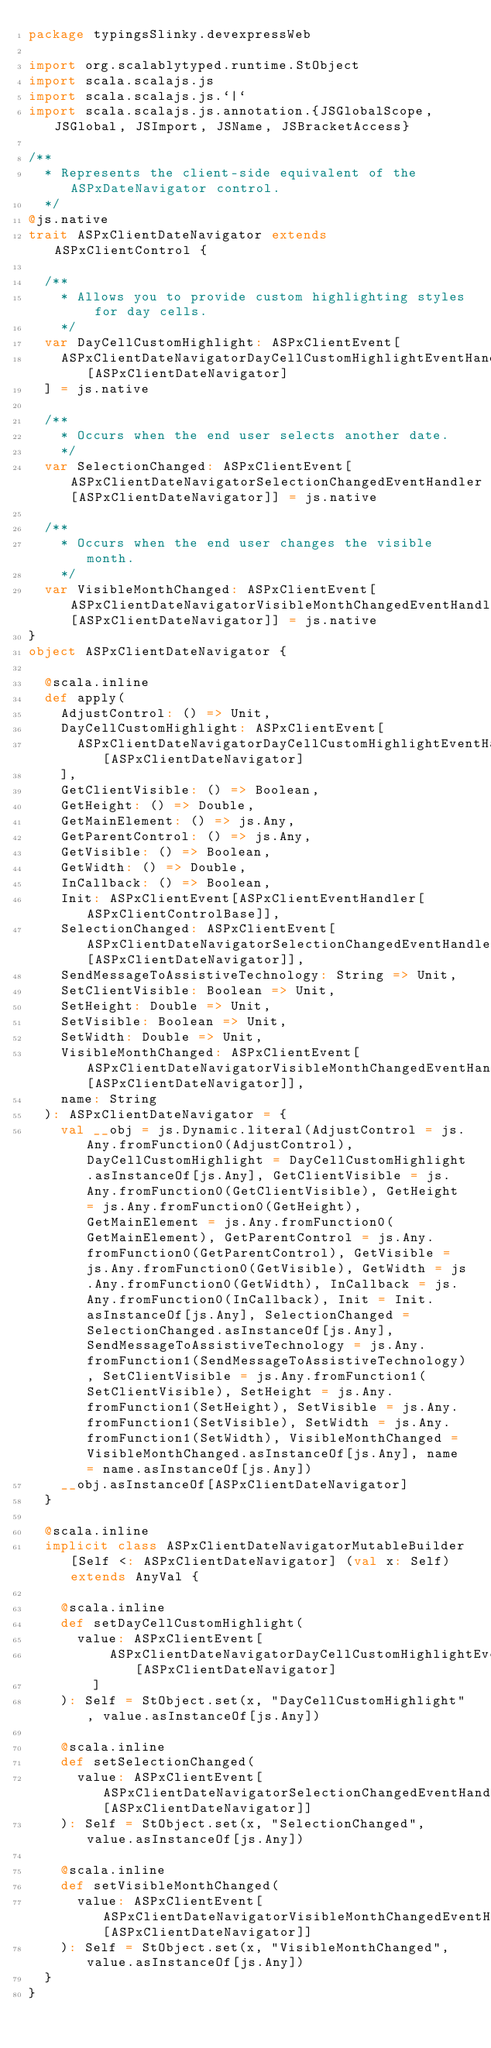<code> <loc_0><loc_0><loc_500><loc_500><_Scala_>package typingsSlinky.devexpressWeb

import org.scalablytyped.runtime.StObject
import scala.scalajs.js
import scala.scalajs.js.`|`
import scala.scalajs.js.annotation.{JSGlobalScope, JSGlobal, JSImport, JSName, JSBracketAccess}

/**
  * Represents the client-side equivalent of the ASPxDateNavigator control.
  */
@js.native
trait ASPxClientDateNavigator extends ASPxClientControl {
  
  /**
    * Allows you to provide custom highlighting styles for day cells.
    */
  var DayCellCustomHighlight: ASPxClientEvent[
    ASPxClientDateNavigatorDayCellCustomHighlightEventHandler[ASPxClientDateNavigator]
  ] = js.native
  
  /**
    * Occurs when the end user selects another date.
    */
  var SelectionChanged: ASPxClientEvent[ASPxClientDateNavigatorSelectionChangedEventHandler[ASPxClientDateNavigator]] = js.native
  
  /**
    * Occurs when the end user changes the visible month.
    */
  var VisibleMonthChanged: ASPxClientEvent[ASPxClientDateNavigatorVisibleMonthChangedEventHandler[ASPxClientDateNavigator]] = js.native
}
object ASPxClientDateNavigator {
  
  @scala.inline
  def apply(
    AdjustControl: () => Unit,
    DayCellCustomHighlight: ASPxClientEvent[
      ASPxClientDateNavigatorDayCellCustomHighlightEventHandler[ASPxClientDateNavigator]
    ],
    GetClientVisible: () => Boolean,
    GetHeight: () => Double,
    GetMainElement: () => js.Any,
    GetParentControl: () => js.Any,
    GetVisible: () => Boolean,
    GetWidth: () => Double,
    InCallback: () => Boolean,
    Init: ASPxClientEvent[ASPxClientEventHandler[ASPxClientControlBase]],
    SelectionChanged: ASPxClientEvent[ASPxClientDateNavigatorSelectionChangedEventHandler[ASPxClientDateNavigator]],
    SendMessageToAssistiveTechnology: String => Unit,
    SetClientVisible: Boolean => Unit,
    SetHeight: Double => Unit,
    SetVisible: Boolean => Unit,
    SetWidth: Double => Unit,
    VisibleMonthChanged: ASPxClientEvent[ASPxClientDateNavigatorVisibleMonthChangedEventHandler[ASPxClientDateNavigator]],
    name: String
  ): ASPxClientDateNavigator = {
    val __obj = js.Dynamic.literal(AdjustControl = js.Any.fromFunction0(AdjustControl), DayCellCustomHighlight = DayCellCustomHighlight.asInstanceOf[js.Any], GetClientVisible = js.Any.fromFunction0(GetClientVisible), GetHeight = js.Any.fromFunction0(GetHeight), GetMainElement = js.Any.fromFunction0(GetMainElement), GetParentControl = js.Any.fromFunction0(GetParentControl), GetVisible = js.Any.fromFunction0(GetVisible), GetWidth = js.Any.fromFunction0(GetWidth), InCallback = js.Any.fromFunction0(InCallback), Init = Init.asInstanceOf[js.Any], SelectionChanged = SelectionChanged.asInstanceOf[js.Any], SendMessageToAssistiveTechnology = js.Any.fromFunction1(SendMessageToAssistiveTechnology), SetClientVisible = js.Any.fromFunction1(SetClientVisible), SetHeight = js.Any.fromFunction1(SetHeight), SetVisible = js.Any.fromFunction1(SetVisible), SetWidth = js.Any.fromFunction1(SetWidth), VisibleMonthChanged = VisibleMonthChanged.asInstanceOf[js.Any], name = name.asInstanceOf[js.Any])
    __obj.asInstanceOf[ASPxClientDateNavigator]
  }
  
  @scala.inline
  implicit class ASPxClientDateNavigatorMutableBuilder[Self <: ASPxClientDateNavigator] (val x: Self) extends AnyVal {
    
    @scala.inline
    def setDayCellCustomHighlight(
      value: ASPxClientEvent[
          ASPxClientDateNavigatorDayCellCustomHighlightEventHandler[ASPxClientDateNavigator]
        ]
    ): Self = StObject.set(x, "DayCellCustomHighlight", value.asInstanceOf[js.Any])
    
    @scala.inline
    def setSelectionChanged(
      value: ASPxClientEvent[ASPxClientDateNavigatorSelectionChangedEventHandler[ASPxClientDateNavigator]]
    ): Self = StObject.set(x, "SelectionChanged", value.asInstanceOf[js.Any])
    
    @scala.inline
    def setVisibleMonthChanged(
      value: ASPxClientEvent[ASPxClientDateNavigatorVisibleMonthChangedEventHandler[ASPxClientDateNavigator]]
    ): Self = StObject.set(x, "VisibleMonthChanged", value.asInstanceOf[js.Any])
  }
}
</code> 